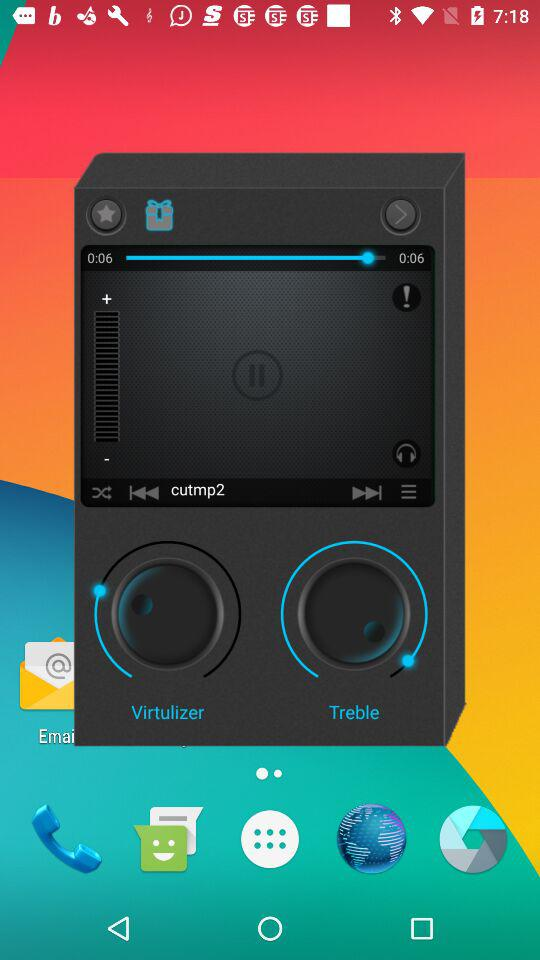What's the song name? The song name is "cutmp2". 